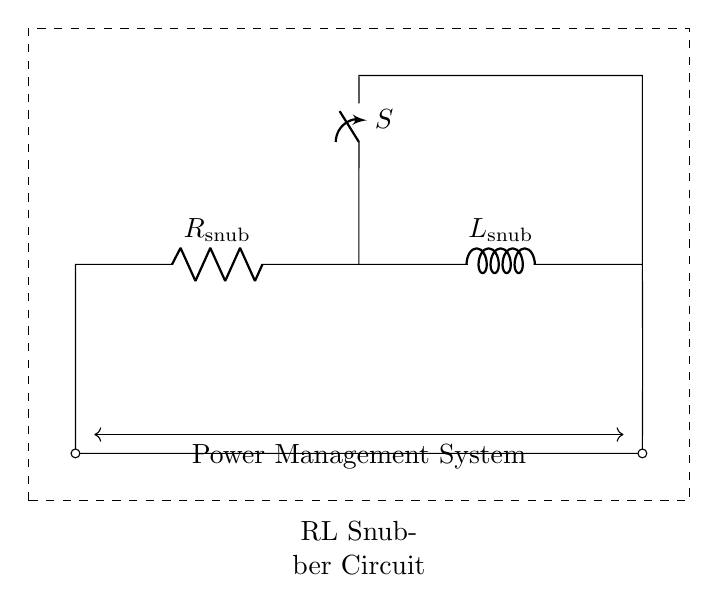What is the value of the resistor in this circuit? The circuit diagram labels the resistor as R_snub. However, a specific numerical value is not provided in the diagram itself. Therefore, the value cannot be determined from just the visual information.
Answer: R_snub What components are present in the snubber circuit? The circuit diagram visually depicts two components: a resistor and an inductor, labeled as R_snub and L_snub respectively. These two components are connected in series.
Answer: Resistor and inductor What is the purpose of the switch in this circuit? The switch, labeled as S in the diagram, is used to control the on/off state of the circuit. When closed, it allows current to flow through the snubber circuit; when open, it interrupts the flow.
Answer: Control current flow What type of circuit is this? This circuit is specifically designed as an RL snubber circuit intended for power management systems, utilizing both a resistor and an inductor for energy dissipation and transient suppression.
Answer: RL snubber circuit How are the resistor and inductor connected in the circuit? In the diagram, the resistor and inductor are connected in series, meaning the output of the resistor feeds directly into the inductor without any branching paths. This configuration is typical for snubber circuits designed to suppress voltage spikes.
Answer: Series connection What does the dashed rectangle represent in the circuit diagram? The dashed rectangle denotes the boundaries of the RL snubber circuit, serving as a visual frame that encapsulates all components and connections within it, clarifying the section of the circuit being described.
Answer: Snubber circuit boundaries 